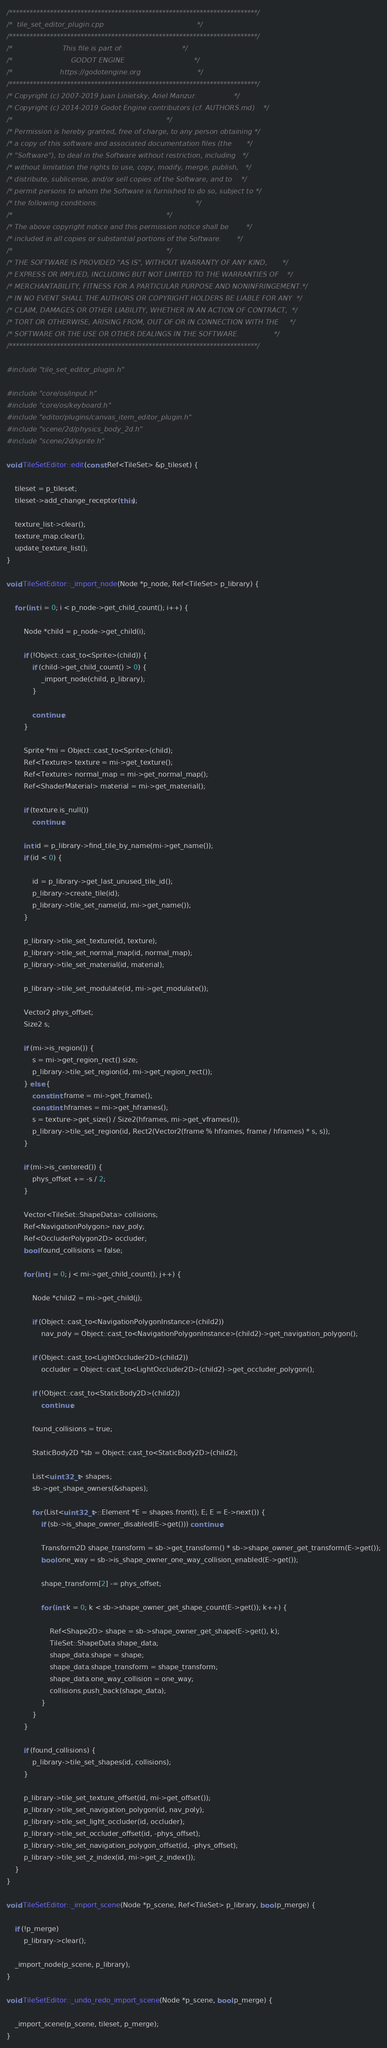Convert code to text. <code><loc_0><loc_0><loc_500><loc_500><_C++_>/*************************************************************************/
/*  tile_set_editor_plugin.cpp                                           */
/*************************************************************************/
/*                       This file is part of:                           */
/*                           GODOT ENGINE                                */
/*                      https://godotengine.org                          */
/*************************************************************************/
/* Copyright (c) 2007-2019 Juan Linietsky, Ariel Manzur.                 */
/* Copyright (c) 2014-2019 Godot Engine contributors (cf. AUTHORS.md)    */
/*                                                                       */
/* Permission is hereby granted, free of charge, to any person obtaining */
/* a copy of this software and associated documentation files (the       */
/* "Software"), to deal in the Software without restriction, including   */
/* without limitation the rights to use, copy, modify, merge, publish,   */
/* distribute, sublicense, and/or sell copies of the Software, and to    */
/* permit persons to whom the Software is furnished to do so, subject to */
/* the following conditions:                                             */
/*                                                                       */
/* The above copyright notice and this permission notice shall be        */
/* included in all copies or substantial portions of the Software.       */
/*                                                                       */
/* THE SOFTWARE IS PROVIDED "AS IS", WITHOUT WARRANTY OF ANY KIND,       */
/* EXPRESS OR IMPLIED, INCLUDING BUT NOT LIMITED TO THE WARRANTIES OF    */
/* MERCHANTABILITY, FITNESS FOR A PARTICULAR PURPOSE AND NONINFRINGEMENT.*/
/* IN NO EVENT SHALL THE AUTHORS OR COPYRIGHT HOLDERS BE LIABLE FOR ANY  */
/* CLAIM, DAMAGES OR OTHER LIABILITY, WHETHER IN AN ACTION OF CONTRACT,  */
/* TORT OR OTHERWISE, ARISING FROM, OUT OF OR IN CONNECTION WITH THE     */
/* SOFTWARE OR THE USE OR OTHER DEALINGS IN THE SOFTWARE.                */
/*************************************************************************/

#include "tile_set_editor_plugin.h"

#include "core/os/input.h"
#include "core/os/keyboard.h"
#include "editor/plugins/canvas_item_editor_plugin.h"
#include "scene/2d/physics_body_2d.h"
#include "scene/2d/sprite.h"

void TileSetEditor::edit(const Ref<TileSet> &p_tileset) {

	tileset = p_tileset;
	tileset->add_change_receptor(this);

	texture_list->clear();
	texture_map.clear();
	update_texture_list();
}

void TileSetEditor::_import_node(Node *p_node, Ref<TileSet> p_library) {

	for (int i = 0; i < p_node->get_child_count(); i++) {

		Node *child = p_node->get_child(i);

		if (!Object::cast_to<Sprite>(child)) {
			if (child->get_child_count() > 0) {
				_import_node(child, p_library);
			}

			continue;
		}

		Sprite *mi = Object::cast_to<Sprite>(child);
		Ref<Texture> texture = mi->get_texture();
		Ref<Texture> normal_map = mi->get_normal_map();
		Ref<ShaderMaterial> material = mi->get_material();

		if (texture.is_null())
			continue;

		int id = p_library->find_tile_by_name(mi->get_name());
		if (id < 0) {

			id = p_library->get_last_unused_tile_id();
			p_library->create_tile(id);
			p_library->tile_set_name(id, mi->get_name());
		}

		p_library->tile_set_texture(id, texture);
		p_library->tile_set_normal_map(id, normal_map);
		p_library->tile_set_material(id, material);

		p_library->tile_set_modulate(id, mi->get_modulate());

		Vector2 phys_offset;
		Size2 s;

		if (mi->is_region()) {
			s = mi->get_region_rect().size;
			p_library->tile_set_region(id, mi->get_region_rect());
		} else {
			const int frame = mi->get_frame();
			const int hframes = mi->get_hframes();
			s = texture->get_size() / Size2(hframes, mi->get_vframes());
			p_library->tile_set_region(id, Rect2(Vector2(frame % hframes, frame / hframes) * s, s));
		}

		if (mi->is_centered()) {
			phys_offset += -s / 2;
		}

		Vector<TileSet::ShapeData> collisions;
		Ref<NavigationPolygon> nav_poly;
		Ref<OccluderPolygon2D> occluder;
		bool found_collisions = false;

		for (int j = 0; j < mi->get_child_count(); j++) {

			Node *child2 = mi->get_child(j);

			if (Object::cast_to<NavigationPolygonInstance>(child2))
				nav_poly = Object::cast_to<NavigationPolygonInstance>(child2)->get_navigation_polygon();

			if (Object::cast_to<LightOccluder2D>(child2))
				occluder = Object::cast_to<LightOccluder2D>(child2)->get_occluder_polygon();

			if (!Object::cast_to<StaticBody2D>(child2))
				continue;

			found_collisions = true;

			StaticBody2D *sb = Object::cast_to<StaticBody2D>(child2);

			List<uint32_t> shapes;
			sb->get_shape_owners(&shapes);

			for (List<uint32_t>::Element *E = shapes.front(); E; E = E->next()) {
				if (sb->is_shape_owner_disabled(E->get())) continue;

				Transform2D shape_transform = sb->get_transform() * sb->shape_owner_get_transform(E->get());
				bool one_way = sb->is_shape_owner_one_way_collision_enabled(E->get());

				shape_transform[2] -= phys_offset;

				for (int k = 0; k < sb->shape_owner_get_shape_count(E->get()); k++) {

					Ref<Shape2D> shape = sb->shape_owner_get_shape(E->get(), k);
					TileSet::ShapeData shape_data;
					shape_data.shape = shape;
					shape_data.shape_transform = shape_transform;
					shape_data.one_way_collision = one_way;
					collisions.push_back(shape_data);
				}
			}
		}

		if (found_collisions) {
			p_library->tile_set_shapes(id, collisions);
		}

		p_library->tile_set_texture_offset(id, mi->get_offset());
		p_library->tile_set_navigation_polygon(id, nav_poly);
		p_library->tile_set_light_occluder(id, occluder);
		p_library->tile_set_occluder_offset(id, -phys_offset);
		p_library->tile_set_navigation_polygon_offset(id, -phys_offset);
		p_library->tile_set_z_index(id, mi->get_z_index());
	}
}

void TileSetEditor::_import_scene(Node *p_scene, Ref<TileSet> p_library, bool p_merge) {

	if (!p_merge)
		p_library->clear();

	_import_node(p_scene, p_library);
}

void TileSetEditor::_undo_redo_import_scene(Node *p_scene, bool p_merge) {

	_import_scene(p_scene, tileset, p_merge);
}
</code> 